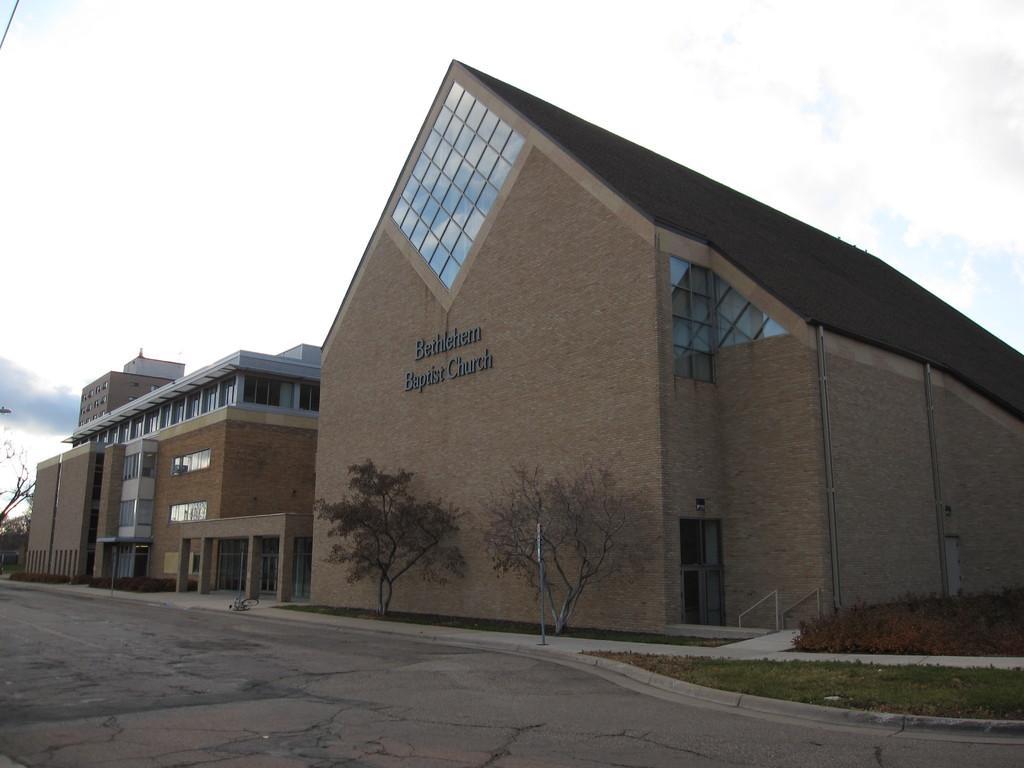In one or two sentences, can you explain what this image depicts? In this picture I can see the buildings on the right side. I can see green grass. I can see trees. I can see clouds in the sky. 